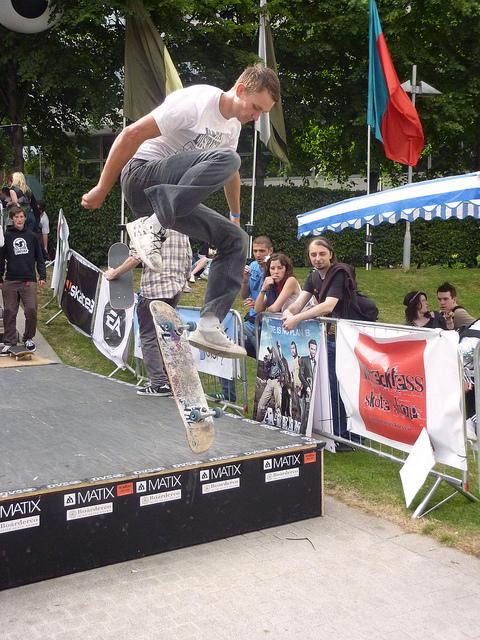What kind of game are they playing?
Answer briefly. Skateboarding. What are the spectators leaning against?
Keep it brief. Railing. Are his feet on the skateboard?
Quick response, please. No. 